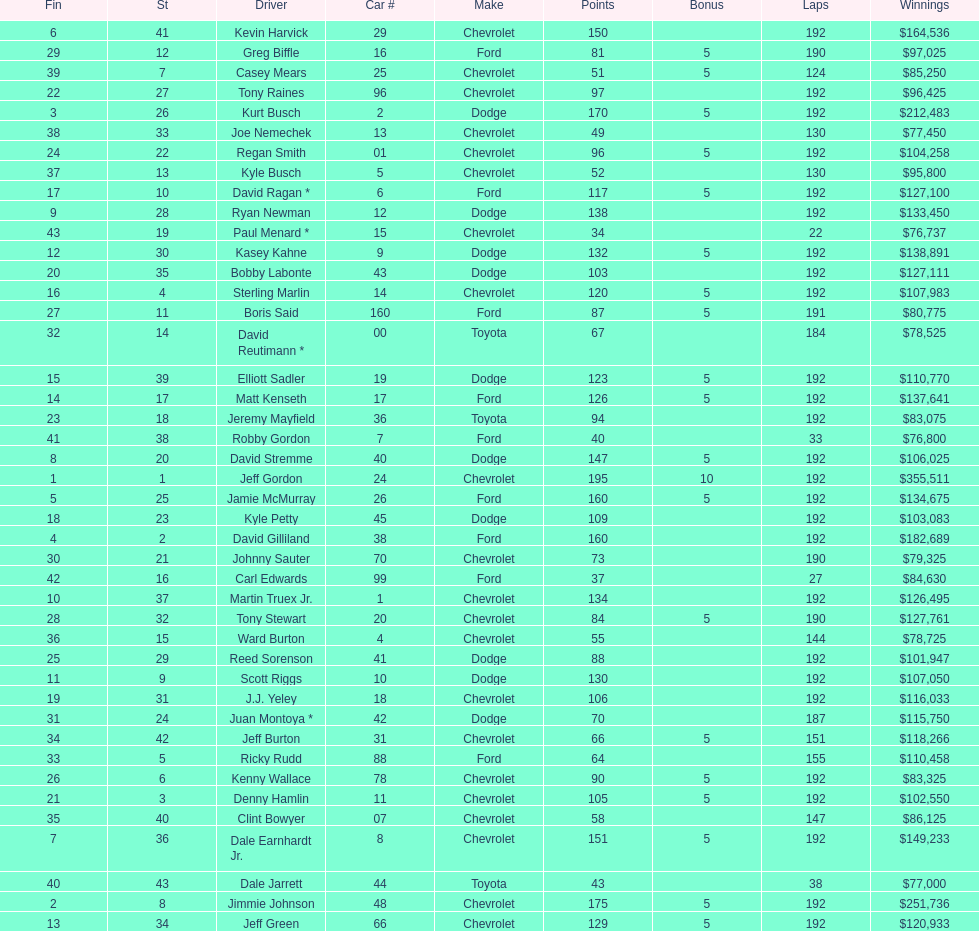Who got the most bonus points? Jeff Gordon. Would you mind parsing the complete table? {'header': ['Fin', 'St', 'Driver', 'Car #', 'Make', 'Points', 'Bonus', 'Laps', 'Winnings'], 'rows': [['6', '41', 'Kevin Harvick', '29', 'Chevrolet', '150', '', '192', '$164,536'], ['29', '12', 'Greg Biffle', '16', 'Ford', '81', '5', '190', '$97,025'], ['39', '7', 'Casey Mears', '25', 'Chevrolet', '51', '5', '124', '$85,250'], ['22', '27', 'Tony Raines', '96', 'Chevrolet', '97', '', '192', '$96,425'], ['3', '26', 'Kurt Busch', '2', 'Dodge', '170', '5', '192', '$212,483'], ['38', '33', 'Joe Nemechek', '13', 'Chevrolet', '49', '', '130', '$77,450'], ['24', '22', 'Regan Smith', '01', 'Chevrolet', '96', '5', '192', '$104,258'], ['37', '13', 'Kyle Busch', '5', 'Chevrolet', '52', '', '130', '$95,800'], ['17', '10', 'David Ragan *', '6', 'Ford', '117', '5', '192', '$127,100'], ['9', '28', 'Ryan Newman', '12', 'Dodge', '138', '', '192', '$133,450'], ['43', '19', 'Paul Menard *', '15', 'Chevrolet', '34', '', '22', '$76,737'], ['12', '30', 'Kasey Kahne', '9', 'Dodge', '132', '5', '192', '$138,891'], ['20', '35', 'Bobby Labonte', '43', 'Dodge', '103', '', '192', '$127,111'], ['16', '4', 'Sterling Marlin', '14', 'Chevrolet', '120', '5', '192', '$107,983'], ['27', '11', 'Boris Said', '160', 'Ford', '87', '5', '191', '$80,775'], ['32', '14', 'David Reutimann *', '00', 'Toyota', '67', '', '184', '$78,525'], ['15', '39', 'Elliott Sadler', '19', 'Dodge', '123', '5', '192', '$110,770'], ['14', '17', 'Matt Kenseth', '17', 'Ford', '126', '5', '192', '$137,641'], ['23', '18', 'Jeremy Mayfield', '36', 'Toyota', '94', '', '192', '$83,075'], ['41', '38', 'Robby Gordon', '7', 'Ford', '40', '', '33', '$76,800'], ['8', '20', 'David Stremme', '40', 'Dodge', '147', '5', '192', '$106,025'], ['1', '1', 'Jeff Gordon', '24', 'Chevrolet', '195', '10', '192', '$355,511'], ['5', '25', 'Jamie McMurray', '26', 'Ford', '160', '5', '192', '$134,675'], ['18', '23', 'Kyle Petty', '45', 'Dodge', '109', '', '192', '$103,083'], ['4', '2', 'David Gilliland', '38', 'Ford', '160', '', '192', '$182,689'], ['30', '21', 'Johnny Sauter', '70', 'Chevrolet', '73', '', '190', '$79,325'], ['42', '16', 'Carl Edwards', '99', 'Ford', '37', '', '27', '$84,630'], ['10', '37', 'Martin Truex Jr.', '1', 'Chevrolet', '134', '', '192', '$126,495'], ['28', '32', 'Tony Stewart', '20', 'Chevrolet', '84', '5', '190', '$127,761'], ['36', '15', 'Ward Burton', '4', 'Chevrolet', '55', '', '144', '$78,725'], ['25', '29', 'Reed Sorenson', '41', 'Dodge', '88', '', '192', '$101,947'], ['11', '9', 'Scott Riggs', '10', 'Dodge', '130', '', '192', '$107,050'], ['19', '31', 'J.J. Yeley', '18', 'Chevrolet', '106', '', '192', '$116,033'], ['31', '24', 'Juan Montoya *', '42', 'Dodge', '70', '', '187', '$115,750'], ['34', '42', 'Jeff Burton', '31', 'Chevrolet', '66', '5', '151', '$118,266'], ['33', '5', 'Ricky Rudd', '88', 'Ford', '64', '', '155', '$110,458'], ['26', '6', 'Kenny Wallace', '78', 'Chevrolet', '90', '5', '192', '$83,325'], ['21', '3', 'Denny Hamlin', '11', 'Chevrolet', '105', '5', '192', '$102,550'], ['35', '40', 'Clint Bowyer', '07', 'Chevrolet', '58', '', '147', '$86,125'], ['7', '36', 'Dale Earnhardt Jr.', '8', 'Chevrolet', '151', '5', '192', '$149,233'], ['40', '43', 'Dale Jarrett', '44', 'Toyota', '43', '', '38', '$77,000'], ['2', '8', 'Jimmie Johnson', '48', 'Chevrolet', '175', '5', '192', '$251,736'], ['13', '34', 'Jeff Green', '66', 'Chevrolet', '129', '5', '192', '$120,933']]} 